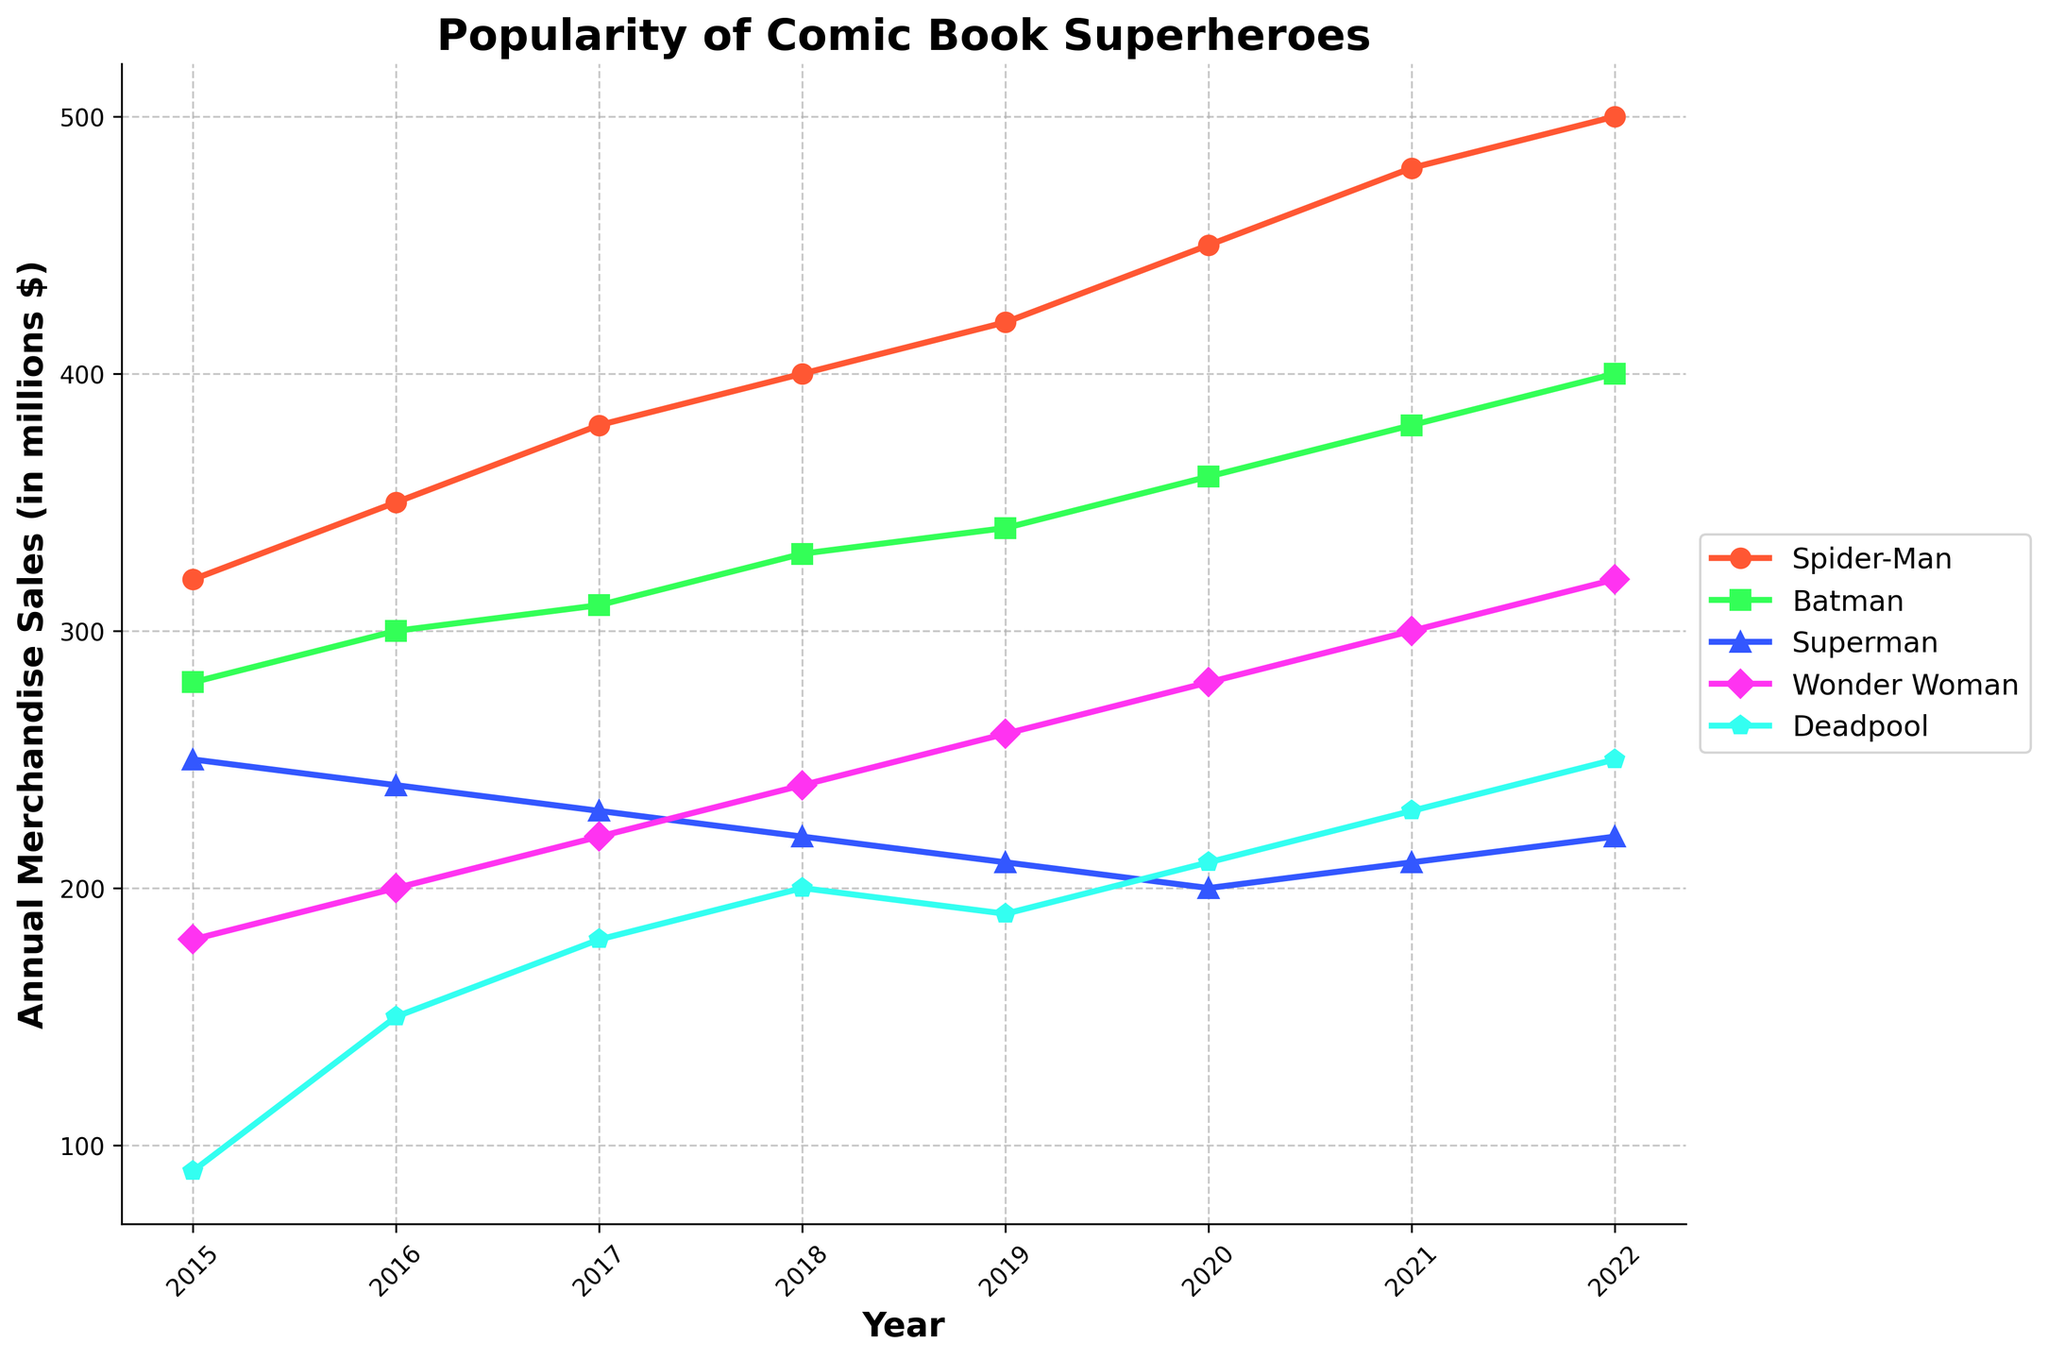Which superhero had the highest merchandise sales in 2022? Look at the endpoint of each line corresponding to 2022. The line for Spider-Man is the highest.
Answer: Spider-Man What was the trend in merchandise sales for Wonder Woman from 2015 to 2022? Observing the plot for Wonder Woman, sales consistently increased from 2015 to 2022.
Answer: Increasing Which superhero experienced the largest increase in merchandise sales between 2015 to 2022? Calculate the increase for each superhero from 2015 to 2022: Spider-Man (500 - 320 = 180), Batman (400 - 280 = 120), Superman (220 - 250 = -30), Wonder Woman (320 - 180 = 140), Deadpool (250 - 90 = 160). Spider-Man has the largest increase.
Answer: Spider-Man In which year did Deadpool see a sudden significant change in merchandise sales and describe it? Examine the slope of Deadpool's line. The sharp increase occurs between 2015 (90) and 2016 (150), an increase of 60.
Answer: 2016, Significant Increase By how much did Spider-Man's merchandise sales surpass Batman's sales in 2020? For 2020, Spider-Man's sales are 450, and Batman's are 360. The difference is 450 - 360 = 90.
Answer: 90 Compare the merchandise sales trends of Superman and Wonder Woman between 2018 and 2020. For Superman, sales decreased (220 to 200). For Wonder Woman, sales increased (240 to 280). So, Superman shows a decreasing trend and Wonder Woman shows an increasing trend.
Answer: Superman decreasing, Wonder Woman increasing Which superhero had the lowest merchandise sales in 2015? Look at the endpoints corresponding to 2015. Deadpool has the lowest sales at 90.
Answer: Deadpool What is the average annual merchandise sales for Batman from 2015 to 2022? Sum the annual sales for Batman from 2015 to 2022 then divide by the number of years: (280 + 300 + 310 + 330 + 340 + 360 + 380 + 400)/8 = 3000/8 = 375.
Answer: 375 Between which two consecutive years did Superman see the greatest drop in merchandise sales? Compare the decrease in sales year-on-year for Superman: 2015-2016 (250 to 240 = -10), 2016-2017 (240 to 230 = -10), 2017-2018 (230 to 220 = -10), 2018-2019 (220 to 210 = -10), 2019-2020 (210 to 200 = -10), 2020-2021 (200 to 210 = +10), 2021-2022 (210 to 220 = +10). The largest drop happened between 2019 and 2020.
Answer: 2019-2020 